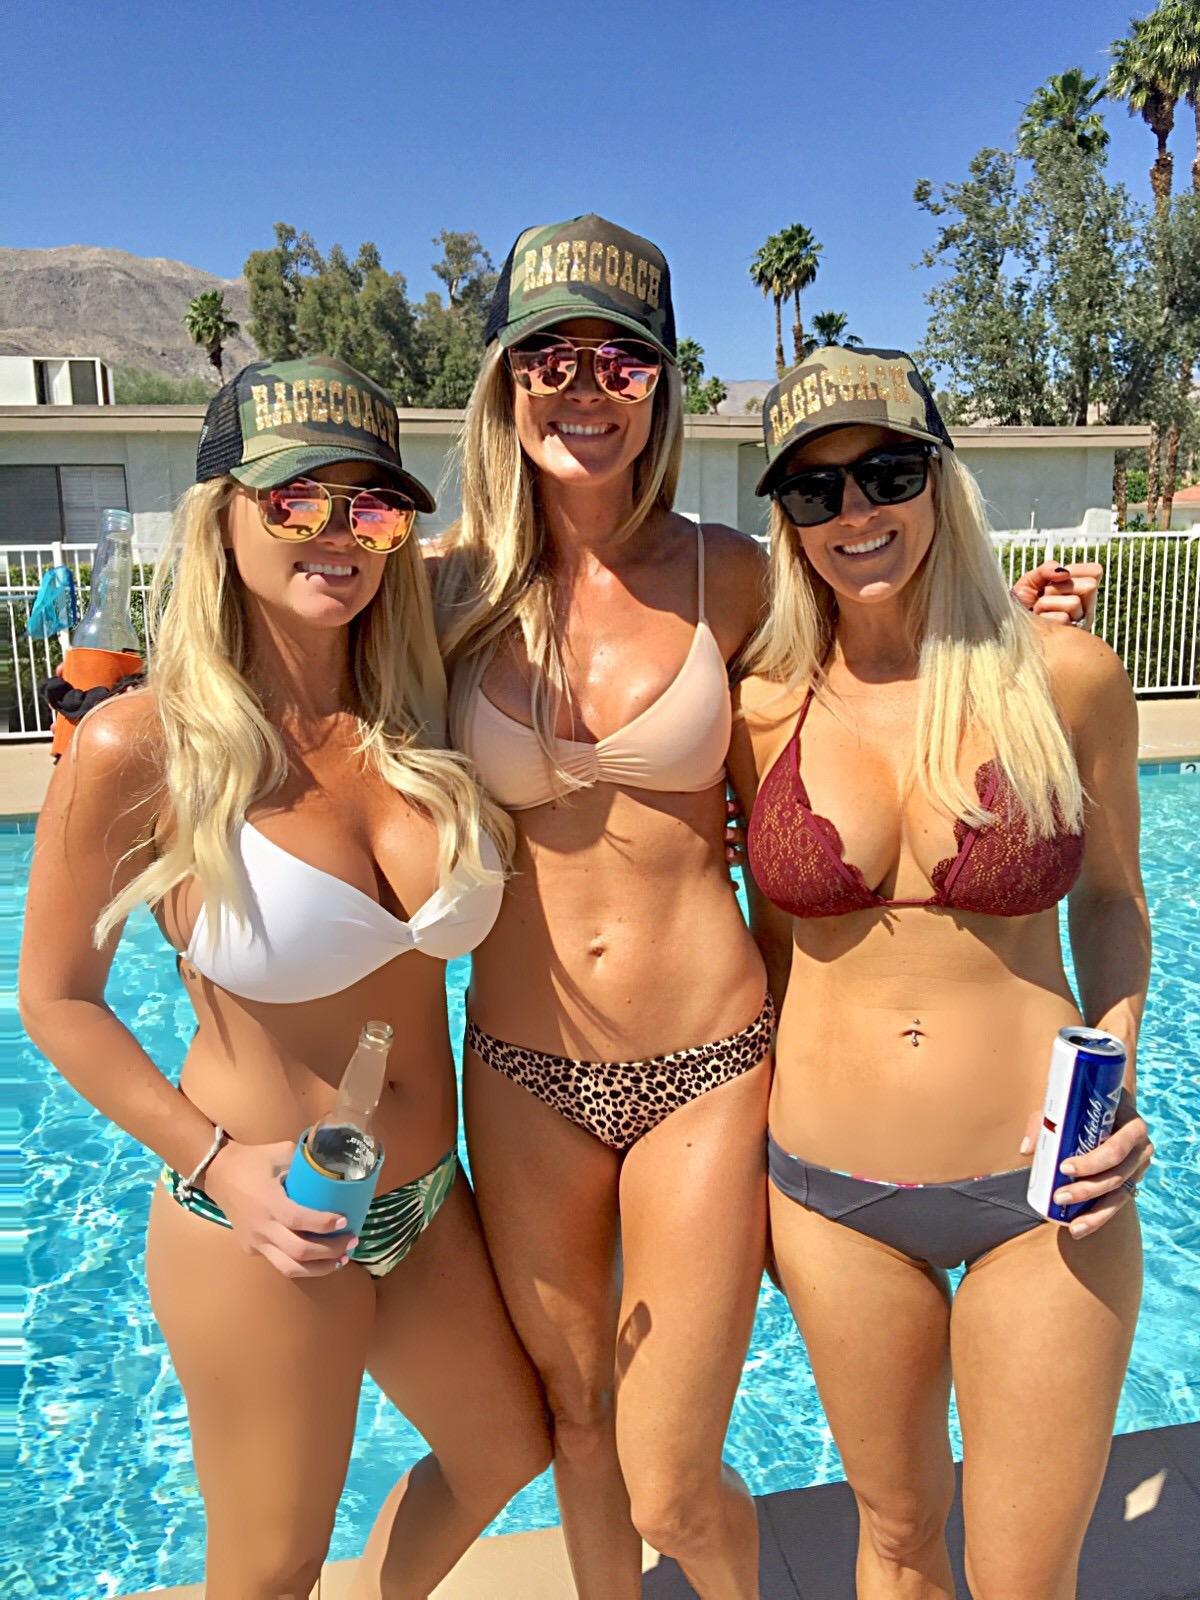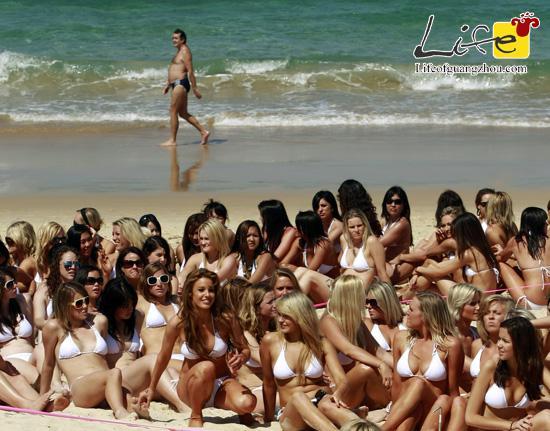The first image is the image on the left, the second image is the image on the right. Given the left and right images, does the statement "One of the images is focused on three girls wearing bikinis." hold true? Answer yes or no. Yes. 